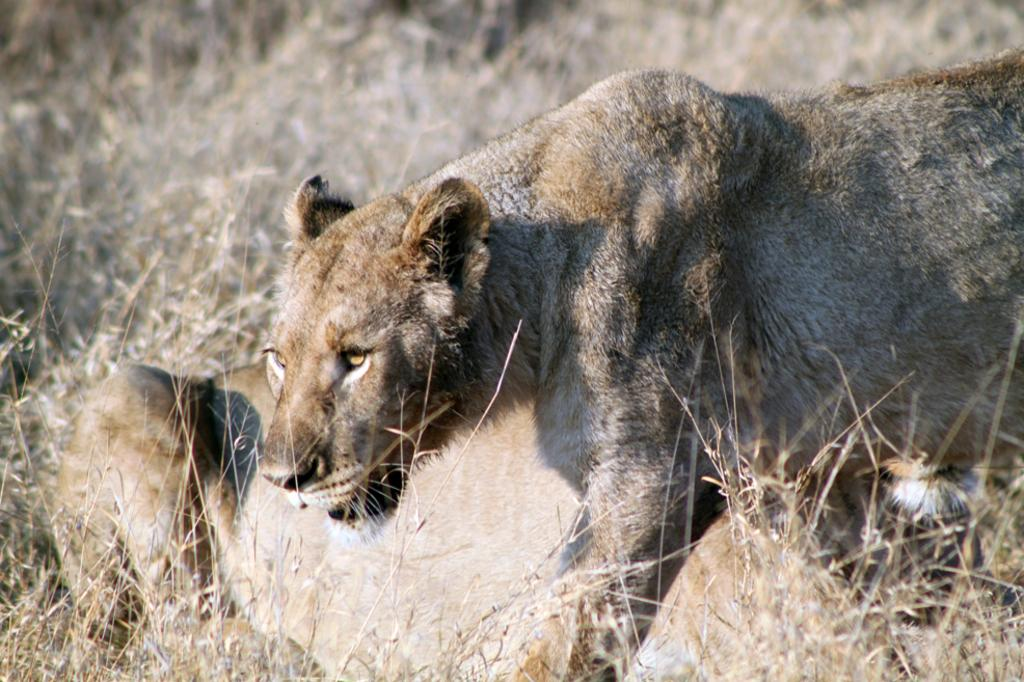What type of animal is present in the image? There is a tiger in the image. Can you describe the position of the second tiger in the image? There is another tiger lying on the ground in the image. What type of vegetation is visible in the image? Grass is visible at the top of the image. What type of note is being distributed by the tiger in the image? There is no note or distribution activity present in the image; it features two tigers and grass. 